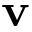<formula> <loc_0><loc_0><loc_500><loc_500>v</formula> 